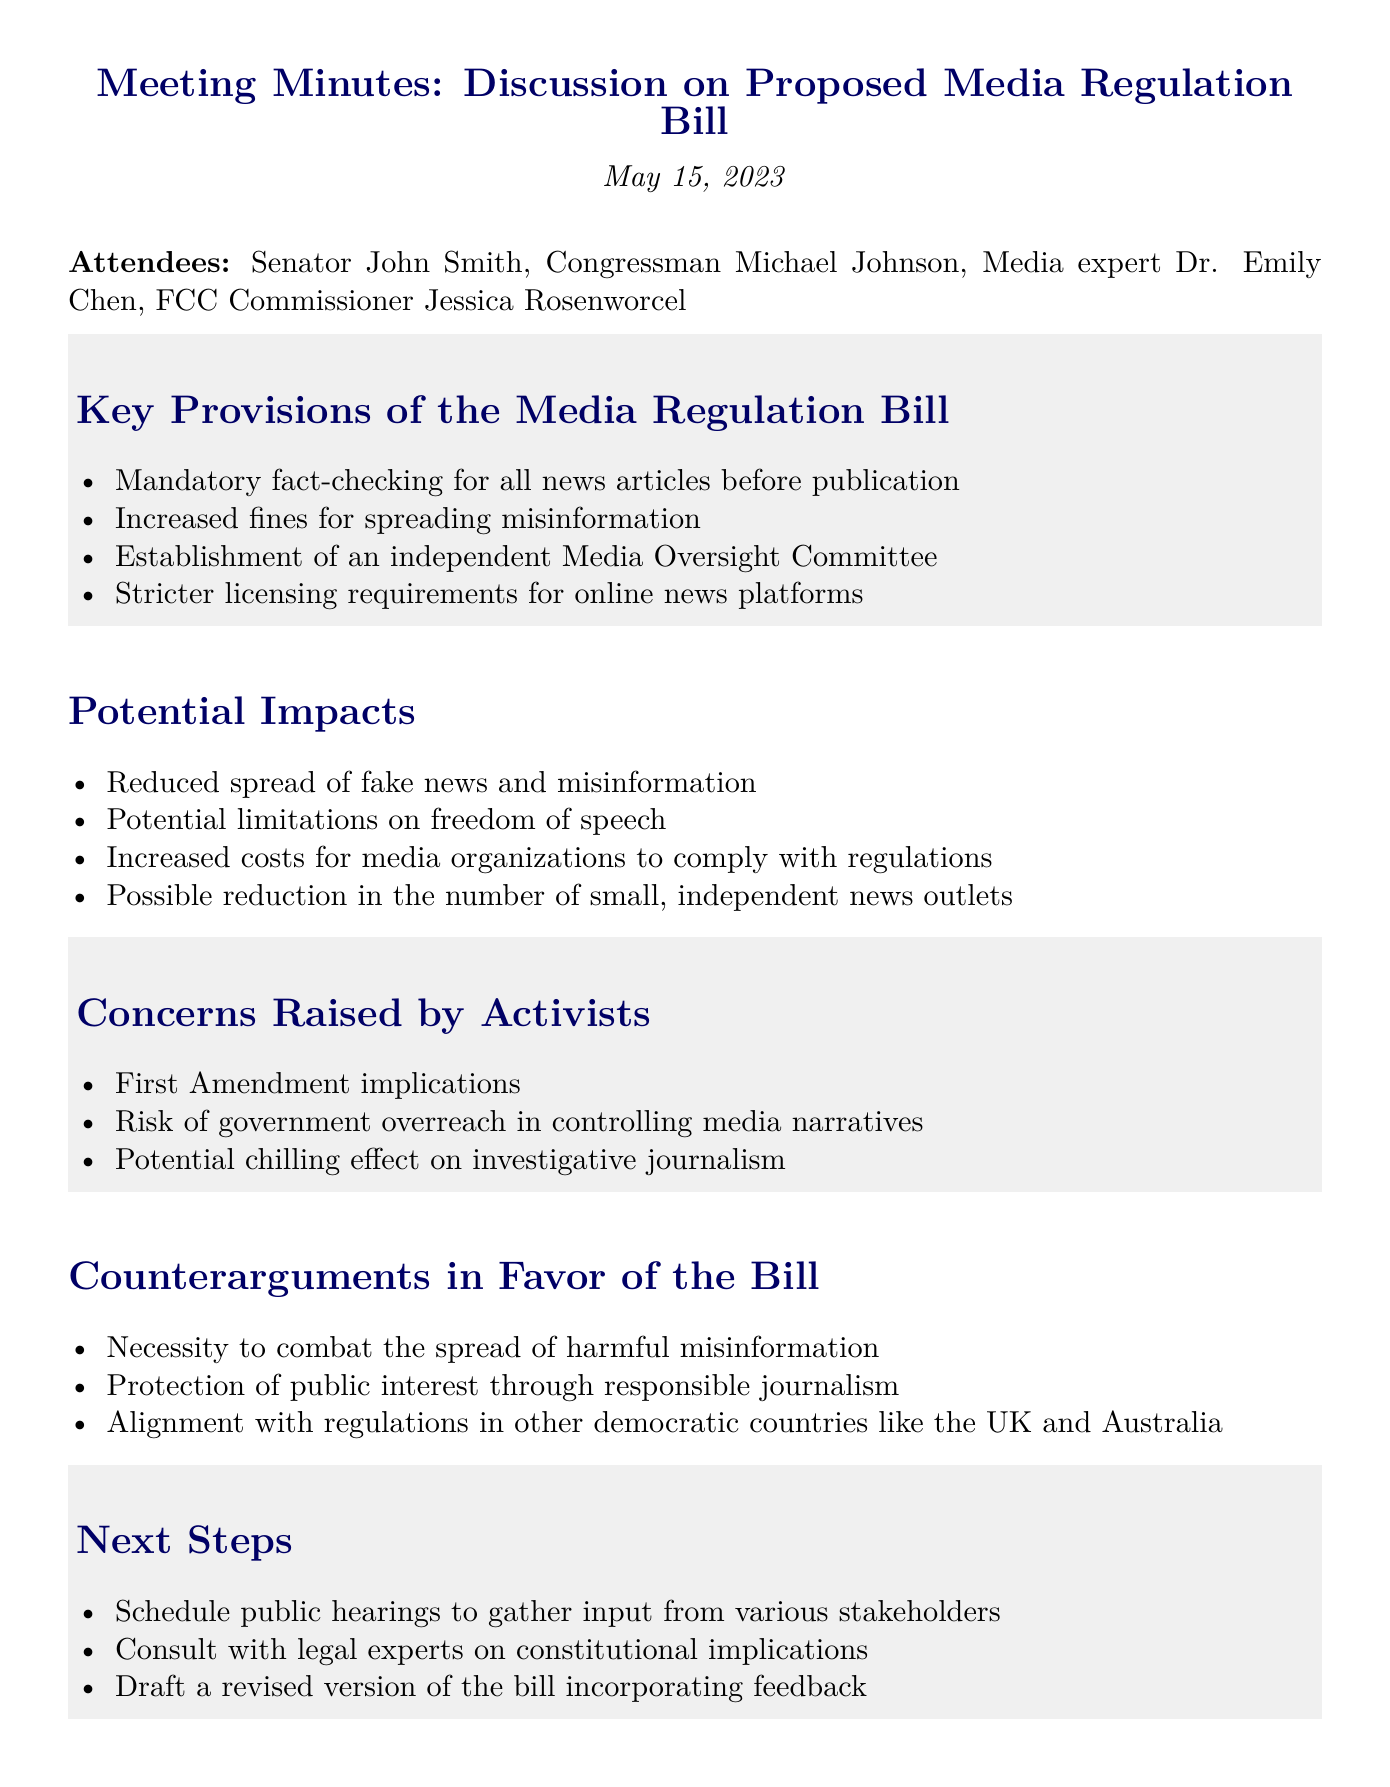What is the date of the meeting? The date of the meeting is mentioned at the beginning of the document.
Answer: May 15, 2023 Who is one of the attendees that is a media expert? The attendees list includes individuals and their professions.
Answer: Dr. Emily Chen What is one of the key provisions related to online news platforms? The document lists key provisions of the bill regarding online news platforms.
Answer: Stricter licensing requirements for online news platforms What potential impact does the bill have on small news outlets? The document discusses potential impacts of the bill, including effects on small news outlets.
Answer: Possible reduction in the number of small, independent news outlets What is a concern raised by activists regarding the bill? The document outlines concerns raised by activists as one of its agenda items.
Answer: First Amendment implications What is a counterargument in favor of the bill? The document enumerates counterarguments supporting the bill, highlighting reasons for its necessity.
Answer: Necessity to combat the spread of harmful misinformation What is the first next step proposed after the meeting? The next steps section outlines actions to take following the meeting discussion.
Answer: Schedule public hearings to gather input from various stakeholders 